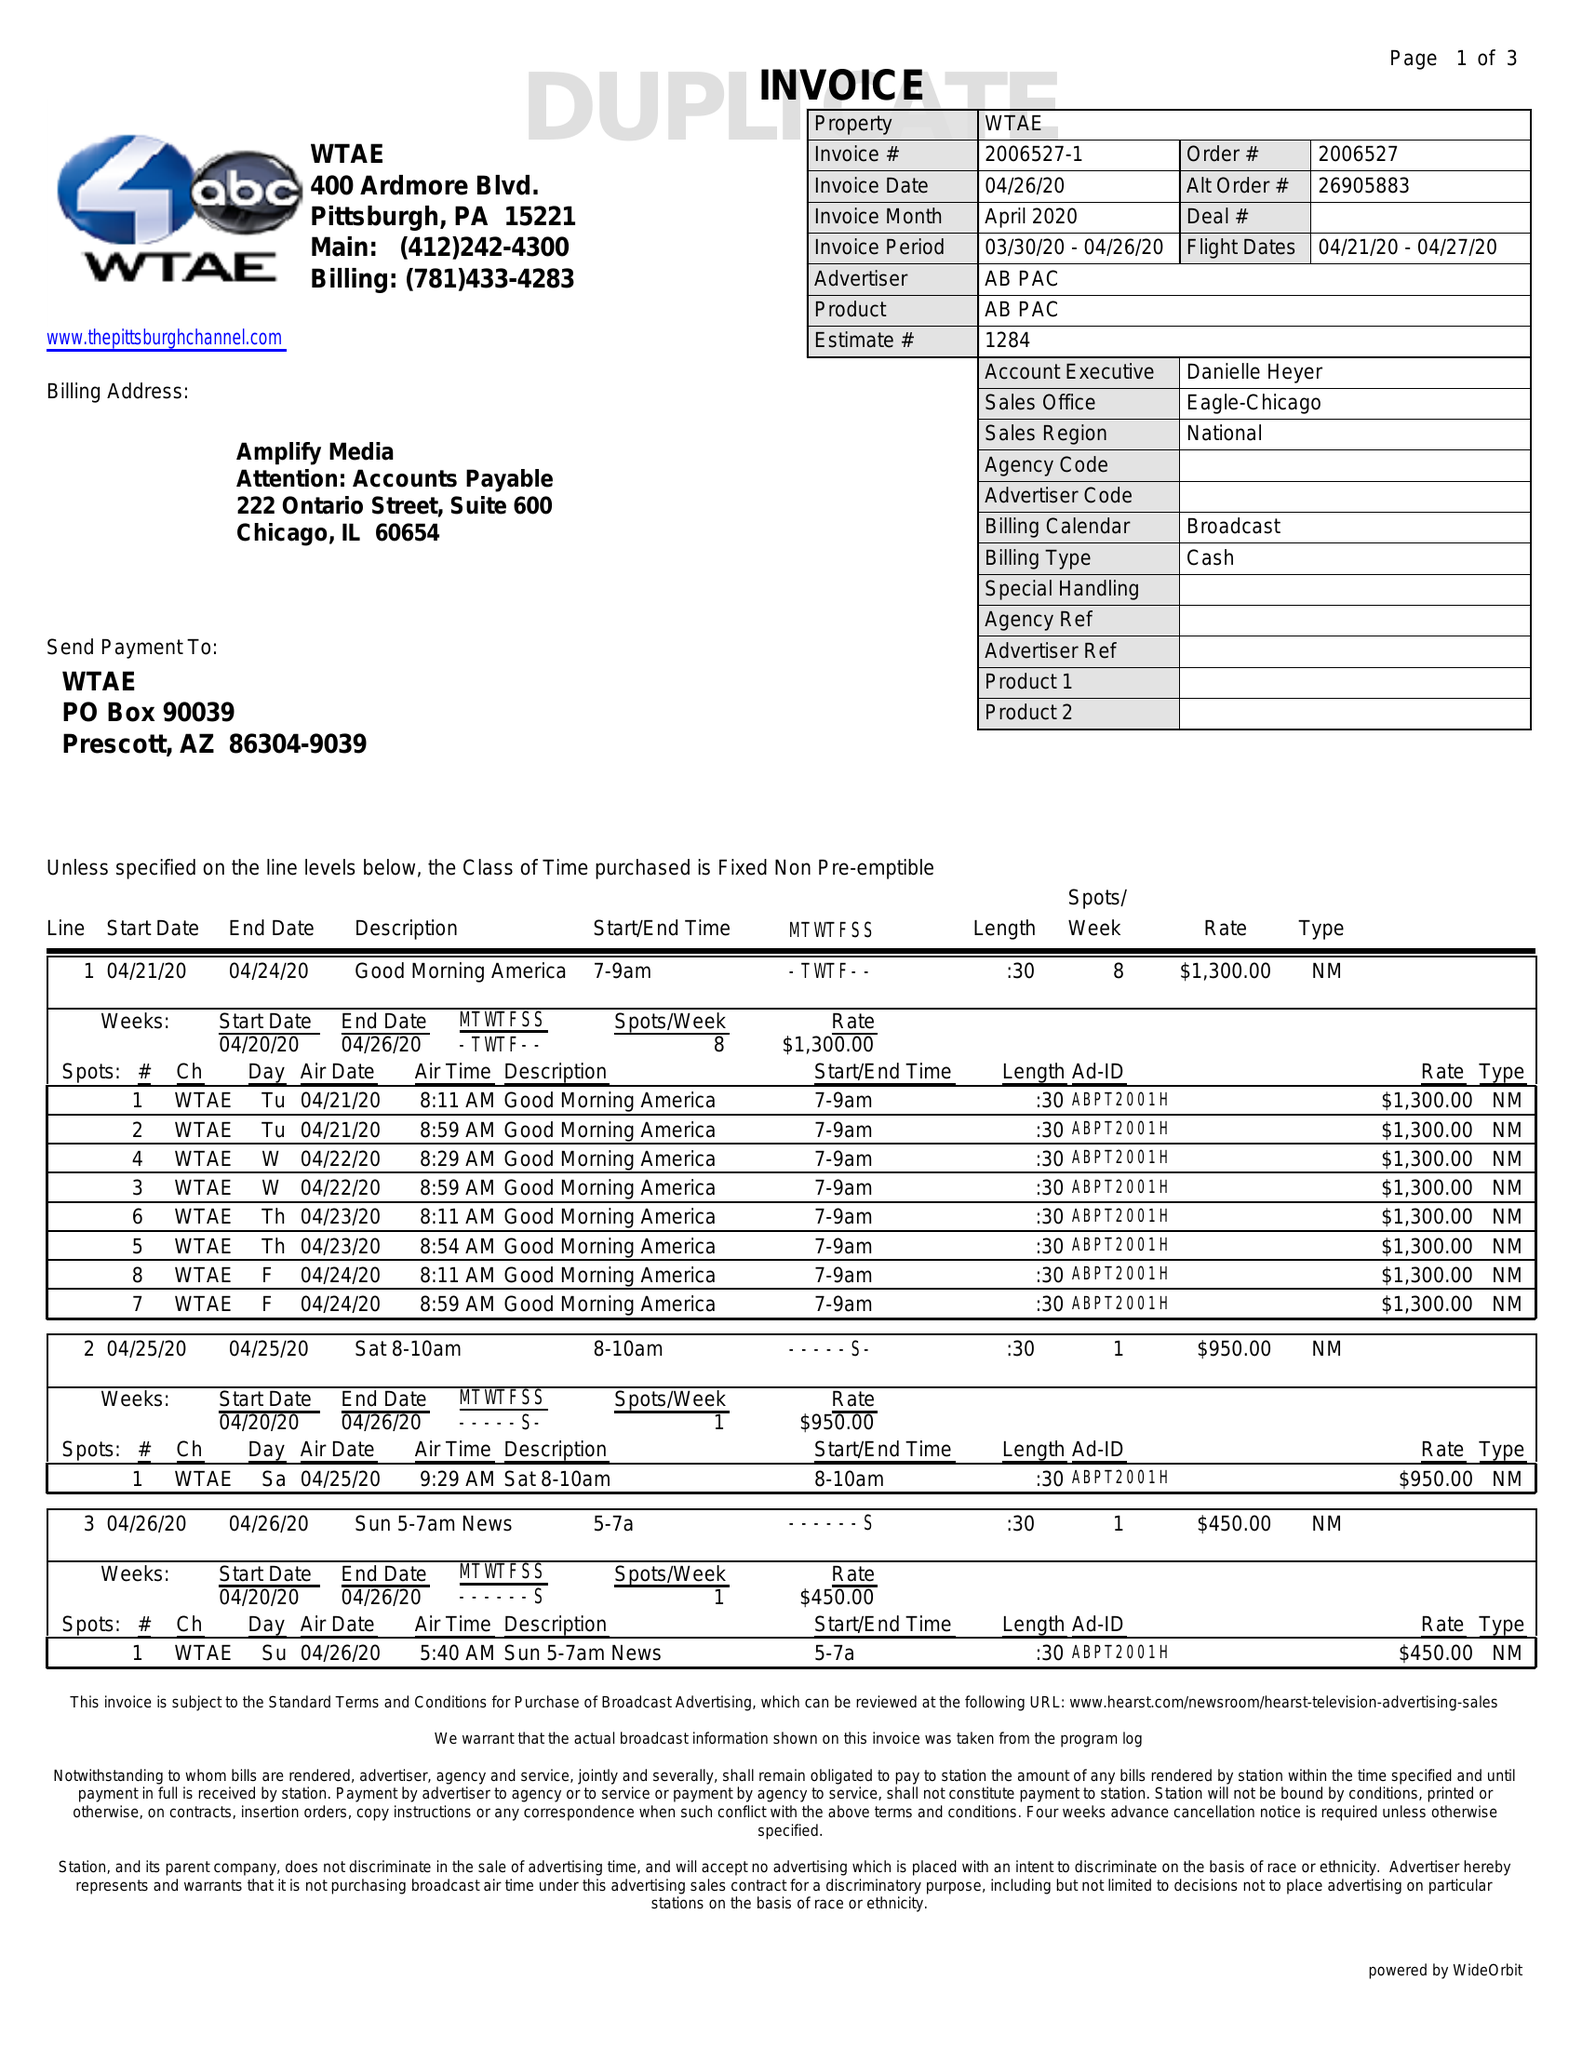What is the value for the advertiser?
Answer the question using a single word or phrase. AB PAC 